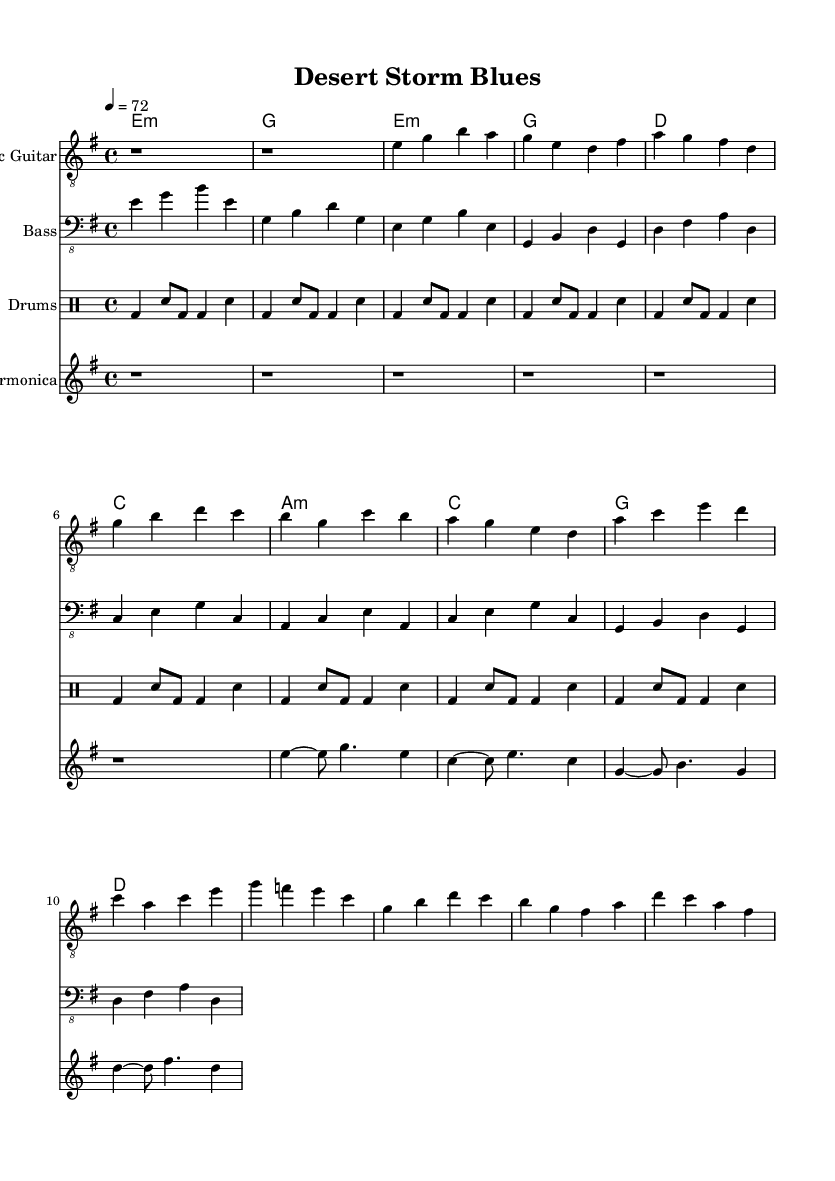What is the key signature of this music? The key signature is shown at the beginning of the staff, indicating E minor. E minor has one sharp (F#).
Answer: E minor What is the time signature of this music? The time signature is indicated in the top left of the sheet music, which is 4/4. This means there are four beats in a measure and a quarter note receives one beat.
Answer: 4/4 What is the tempo marking for this piece? The tempo marking is indicated as "4 = 72," meaning there are 72 beats per minute, with each beat represented by a quarter note.
Answer: 72 How many measures are in the chorus section? By counting the distinct measures identified in the chorus, we see there are 6 measures present.
Answer: 6 What instrument typically leads in Electric Blues as shown in this sheet music? Electric blues often features a leading instrument that expresses the musical theme, which in this case is the Electric Guitar indicated as the main melodic part.
Answer: Electric Guitar What emotional themes are explored in the lyrics based on the music style? Electric blues often conveys strong emotions related to personal struggles and experiences, particularly as it relates to the gritty realities of post-war experiences and PTSD, aligning with the intended thematic focus.
Answer: PTSD 